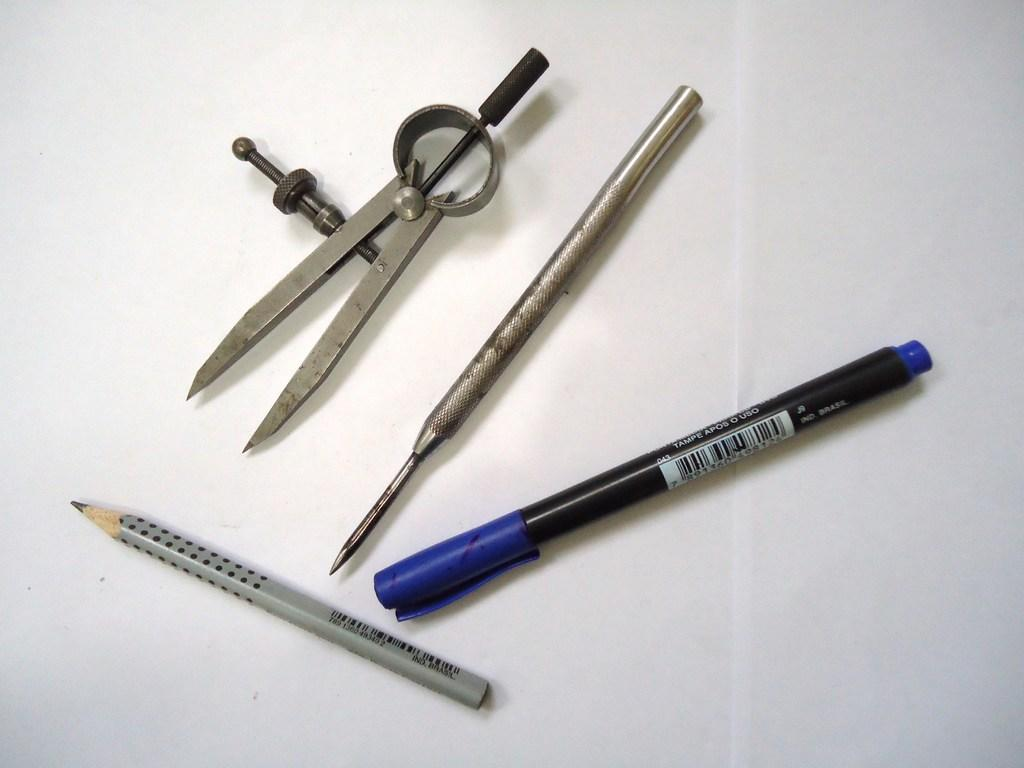What separates the objects in the image? There is a divider in the image. What writing instruments are present in the image? There is a pencil and a pen in the image. What is the object on the white surface in the image? The object on the white surface is not specified, but it could be the pencil or pen. What type of patch is visible on the plantation in the image? There is no patch or plantation present in the image. How many letters are visible on the white surface in the image? The number of letters is not mentioned in the facts, and there is no indication of any letters in the image. 